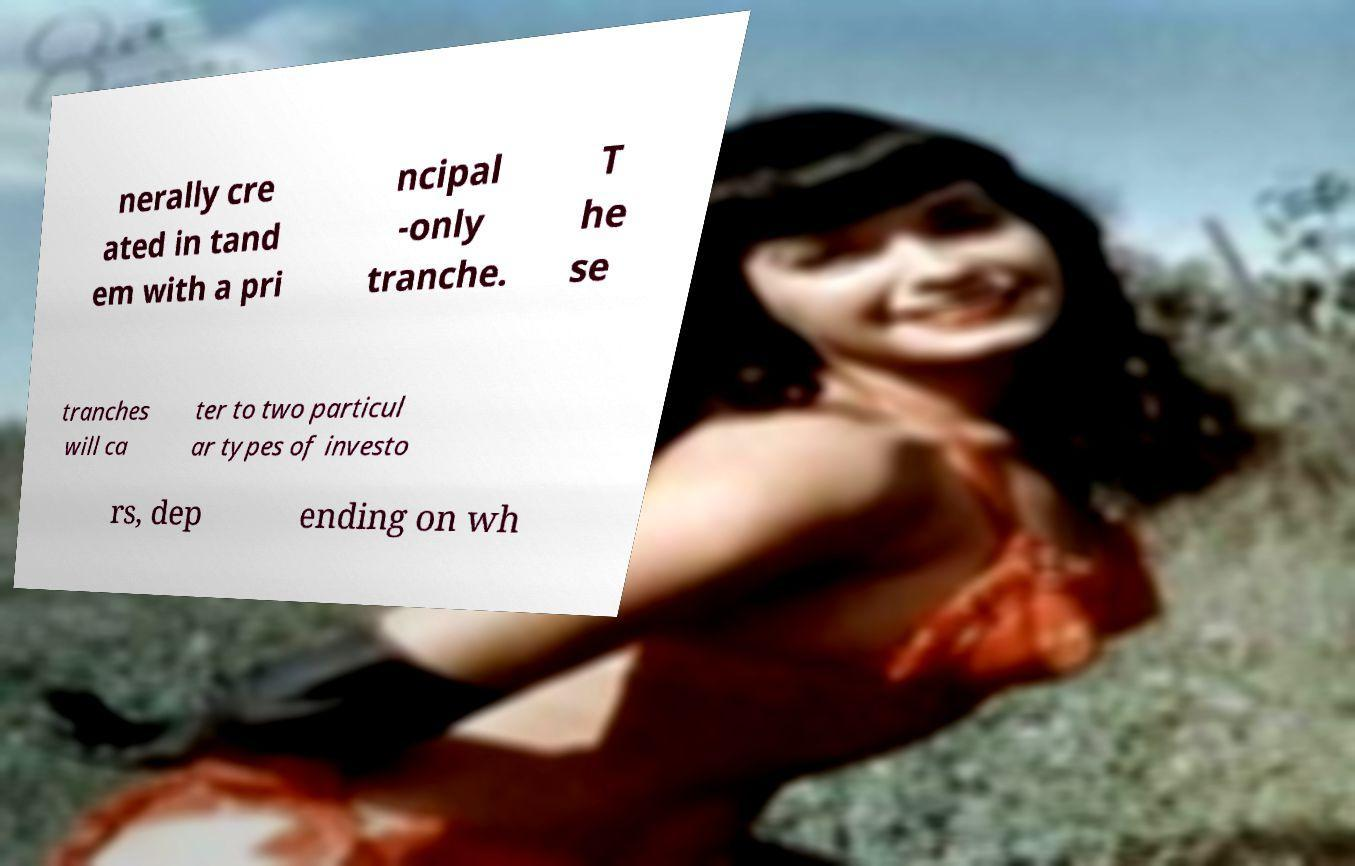Can you accurately transcribe the text from the provided image for me? nerally cre ated in tand em with a pri ncipal -only tranche. T he se tranches will ca ter to two particul ar types of investo rs, dep ending on wh 